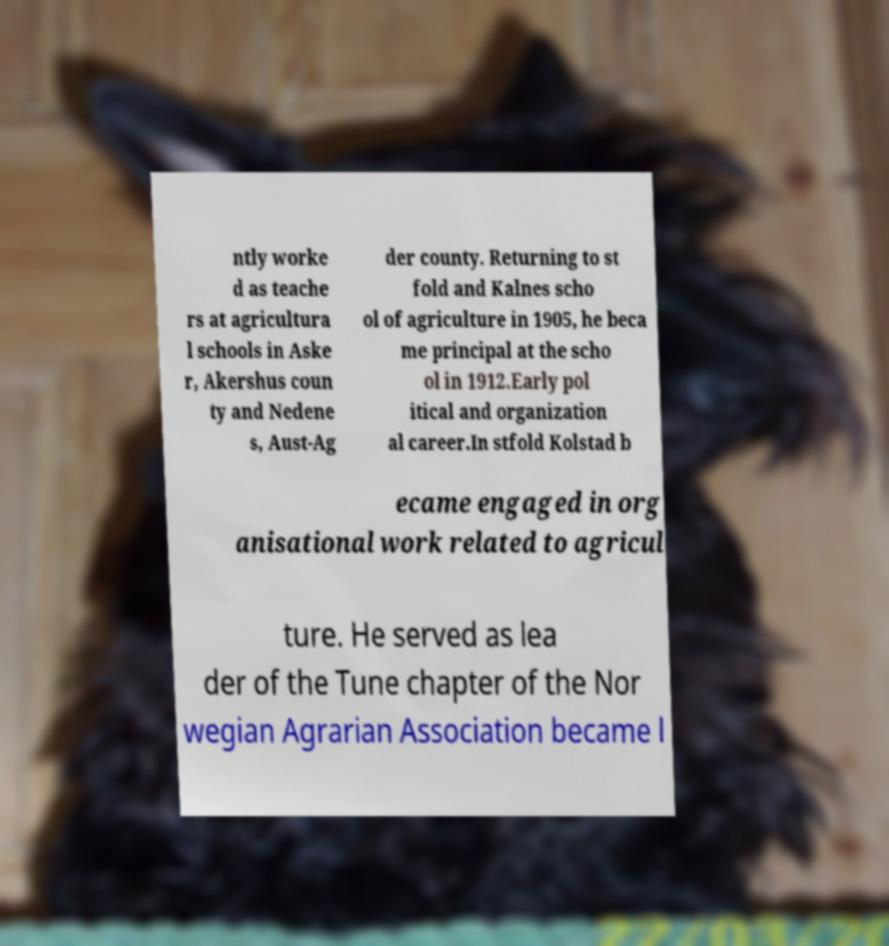Could you assist in decoding the text presented in this image and type it out clearly? ntly worke d as teache rs at agricultura l schools in Aske r, Akershus coun ty and Nedene s, Aust-Ag der county. Returning to st fold and Kalnes scho ol of agriculture in 1905, he beca me principal at the scho ol in 1912.Early pol itical and organization al career.In stfold Kolstad b ecame engaged in org anisational work related to agricul ture. He served as lea der of the Tune chapter of the Nor wegian Agrarian Association became l 